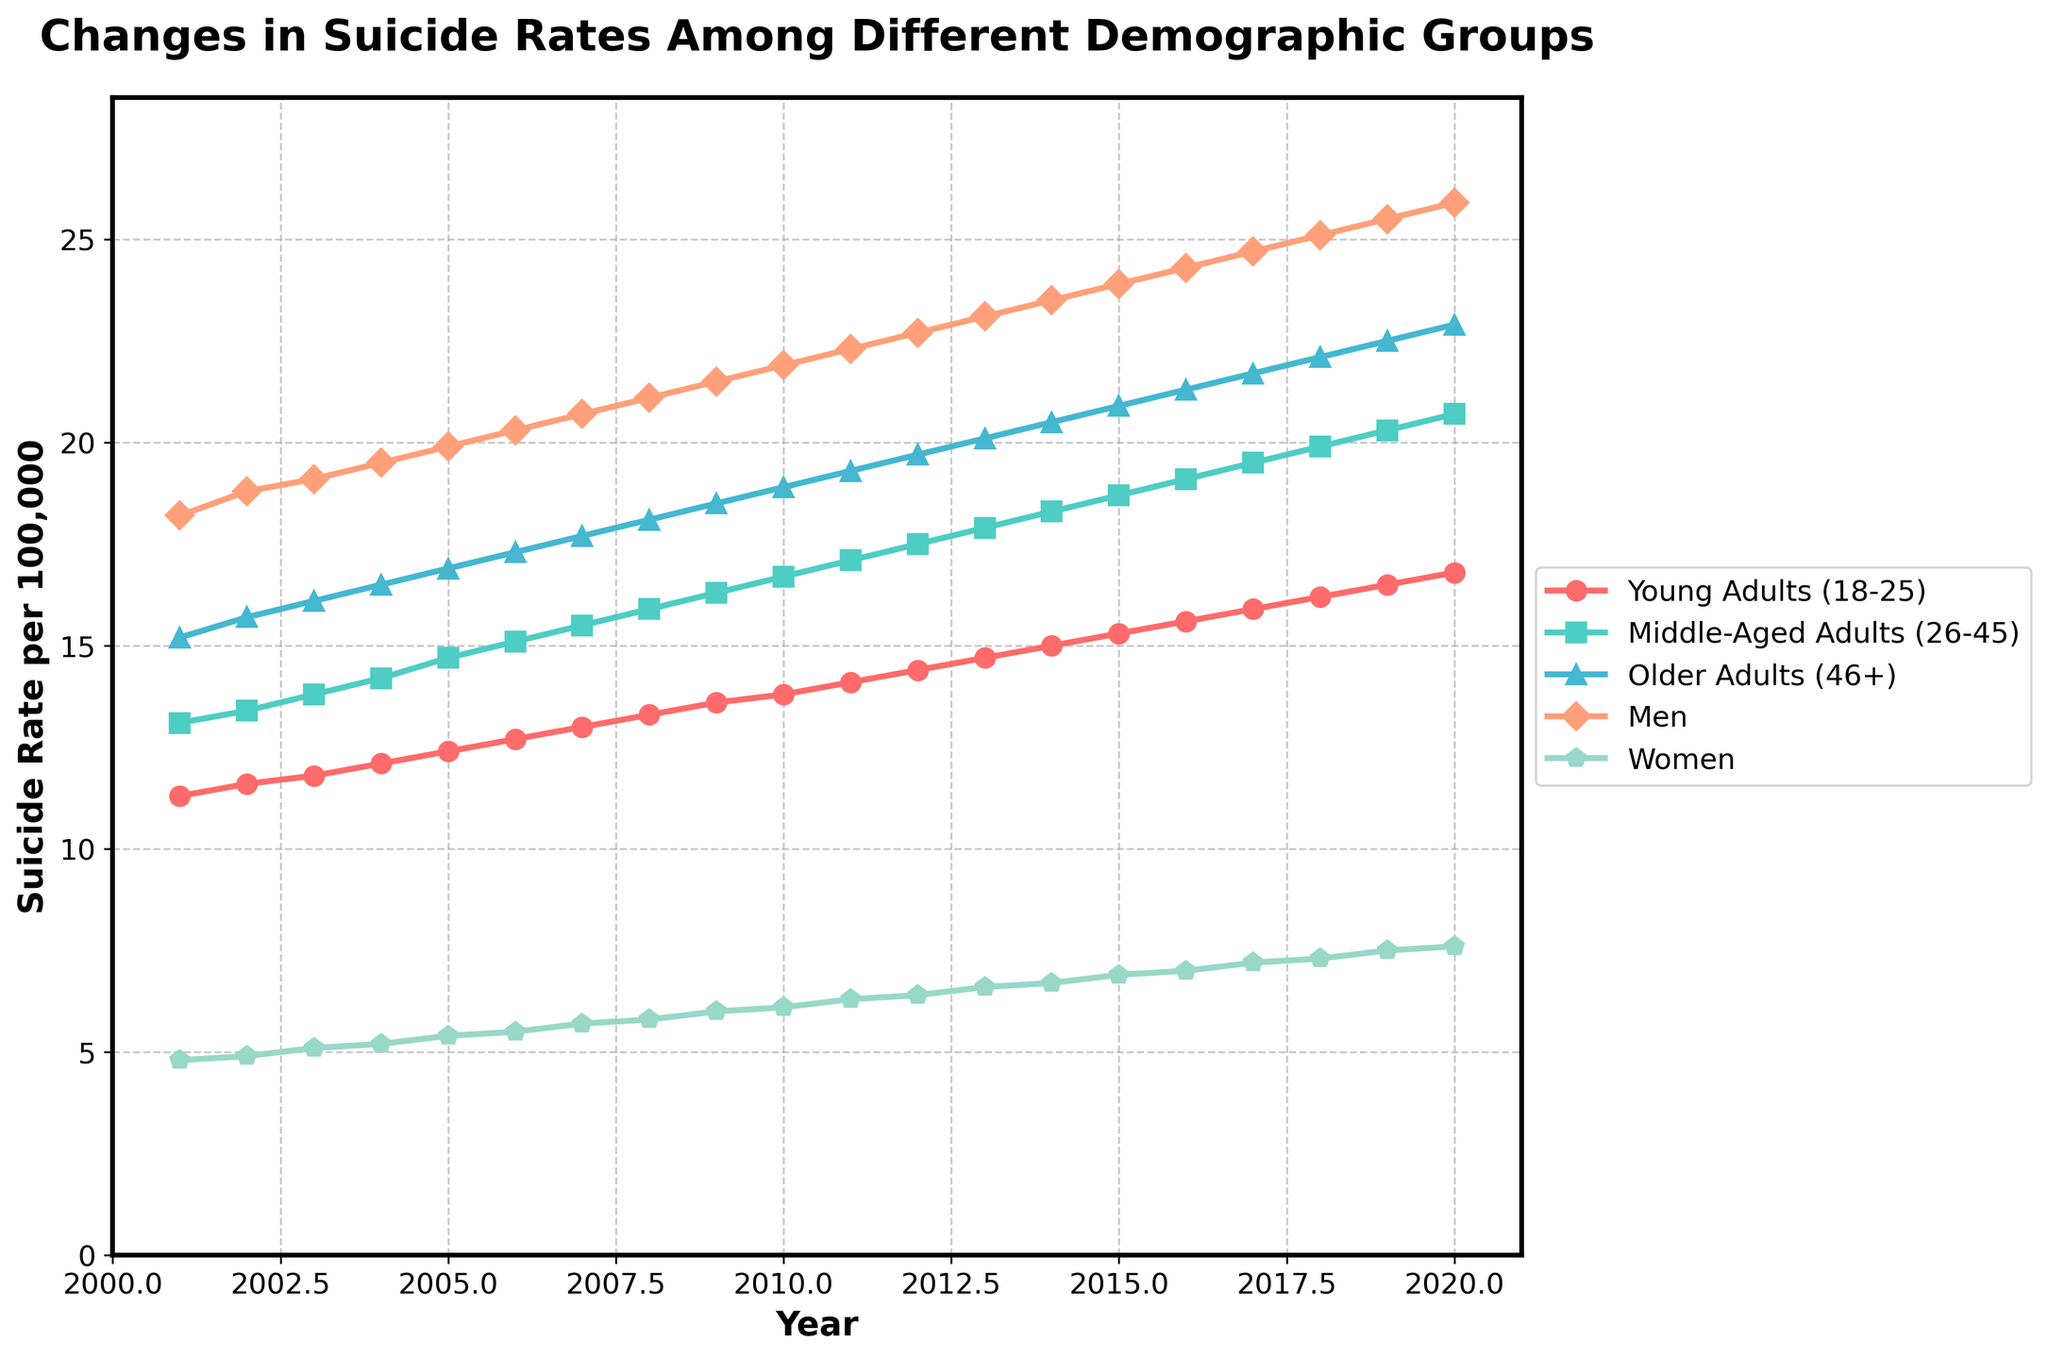Which demographic group had the highest suicide rate in 2020? Look at the values for each demographic group in 2020. The "Men" group has the highest rate at 25.9 per 100,000.
Answer: Men Which group had the smallest increase in suicide rates from 2001 to 2020? Calculate the difference between the 2020 and 2001 rates for each group. "Women" had the smallest increase: 7.6 - 4.8 = 2.8 per 100,000.
Answer: Women Between 2005 to 2010, which group saw the highest percentage increase in suicide rates? Calculate the percentage increase for each group: ((rate_2010 - rate_2005) / rate_2005) * 100. "Men" saw the highest percentage increase: ((21.9 - 19.9) / 19.9) * 100 ≈ 10.05%.
Answer: Men What is the overall trend in suicide rates for middle-aged adults from 2001 to 2020? Examine the line for "Middle-Aged Adults (26-45)" from 2001 to 2020. The trend consistently increases from 13.1 to 20.7 per 100,000.
Answer: Increasing Compare the rate of change in suicide rates between young adults and older adults from 2001 to 2010. Find the differences in rates for both groups between 2001 and 2010. Young adults (18-25) increased by 2.5 (13.8 - 11.3), and older adults (46+) increased by 3.7 (18.9 - 15.2).
Answer: Older adults Which year showed the most significant rise in suicide rates for women? Look at the year-on-year increase in the "Women" line. From 2002 to 2003, the rate increased from 4.9 to 5.1, which is the most significant rise of 0.2 per 100,000 in one year.
Answer: 2003 Considering the entire period, which group's suicide rate line has the steepest slope? Determine the slope for each group's line by analyzing the angle of the line. The "Men" group has the steepest slope due to the largest increase from 18.2 to 25.9, an increase of 7.7.
Answer: Men Which demographic group's suicide rates intersect around 2006, and what is the approximate rate at this point? Observing the chart, the lines for "Young Adults (18-25)" and "Women" intersect around 2006. The approximate rate at the intersection is around 5.5 per 100,000.
Answer: Young Adults and Women, 5.5 